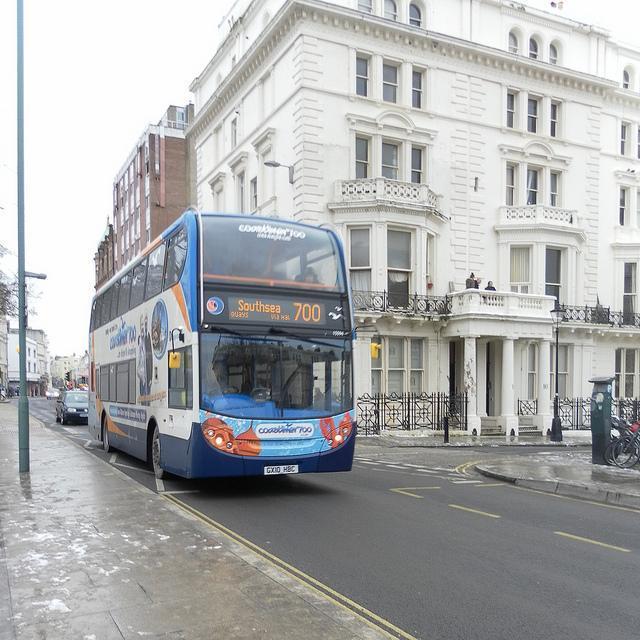How many elephants have tusks?
Give a very brief answer. 0. 